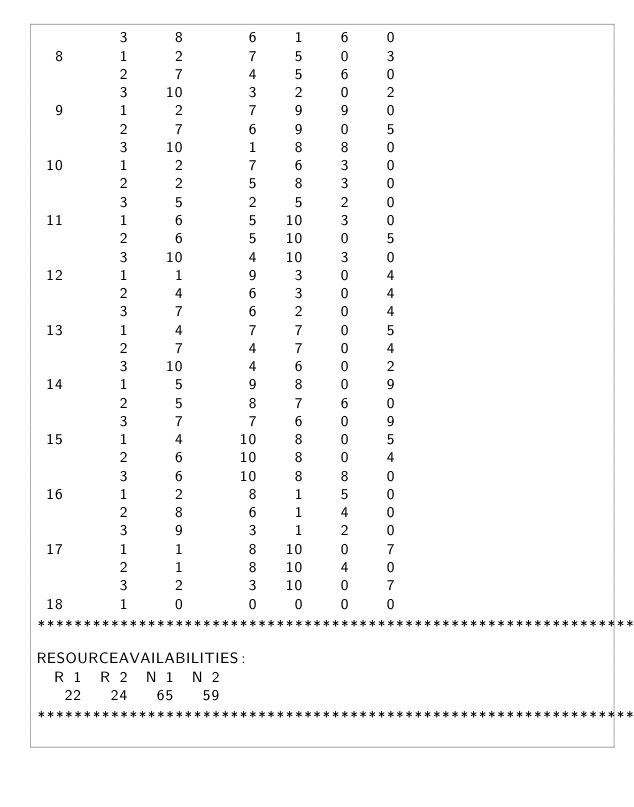Convert code to text. <code><loc_0><loc_0><loc_500><loc_500><_ObjectiveC_>         3     8       6    1    6    0
  8      1     2       7    5    0    3
         2     7       4    5    6    0
         3    10       3    2    0    2
  9      1     2       7    9    9    0
         2     7       6    9    0    5
         3    10       1    8    8    0
 10      1     2       7    6    3    0
         2     2       5    8    3    0
         3     5       2    5    2    0
 11      1     6       5   10    3    0
         2     6       5   10    0    5
         3    10       4   10    3    0
 12      1     1       9    3    0    4
         2     4       6    3    0    4
         3     7       6    2    0    4
 13      1     4       7    7    0    5
         2     7       4    7    0    4
         3    10       4    6    0    2
 14      1     5       9    8    0    9
         2     5       8    7    6    0
         3     7       7    6    0    9
 15      1     4      10    8    0    5
         2     6      10    8    0    4
         3     6      10    8    8    0
 16      1     2       8    1    5    0
         2     8       6    1    4    0
         3     9       3    1    2    0
 17      1     1       8   10    0    7
         2     1       8   10    4    0
         3     2       3   10    0    7
 18      1     0       0    0    0    0
************************************************************************
RESOURCEAVAILABILITIES:
  R 1  R 2  N 1  N 2
   22   24   65   59
************************************************************************
</code> 